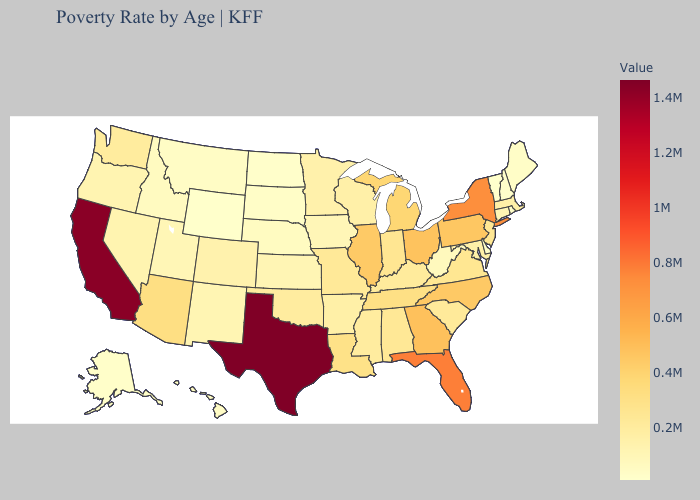Which states have the lowest value in the USA?
Short answer required. Vermont. Does Oklahoma have a higher value than Pennsylvania?
Be succinct. No. Among the states that border Vermont , which have the lowest value?
Answer briefly. New Hampshire. Does Arkansas have the highest value in the USA?
Quick response, please. No. Which states have the lowest value in the MidWest?
Quick response, please. North Dakota. 